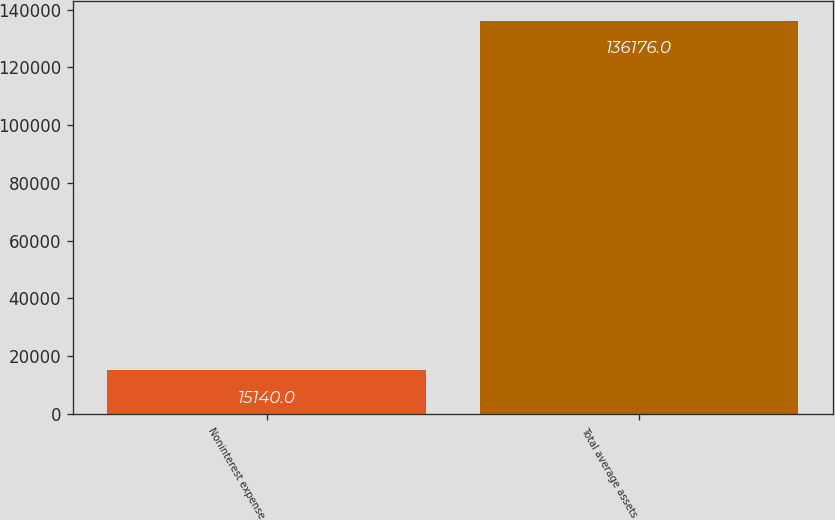Convert chart. <chart><loc_0><loc_0><loc_500><loc_500><bar_chart><fcel>Noninterest expense<fcel>Total average assets<nl><fcel>15140<fcel>136176<nl></chart> 